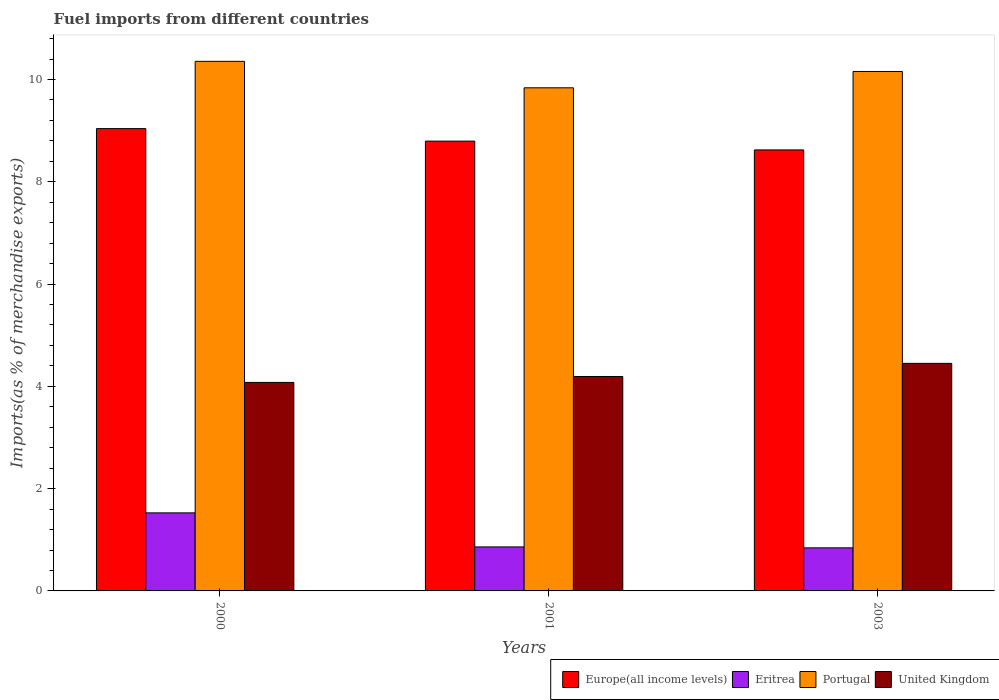How many groups of bars are there?
Provide a short and direct response. 3. Are the number of bars on each tick of the X-axis equal?
Make the answer very short. Yes. How many bars are there on the 3rd tick from the left?
Give a very brief answer. 4. What is the percentage of imports to different countries in Europe(all income levels) in 2001?
Ensure brevity in your answer.  8.8. Across all years, what is the maximum percentage of imports to different countries in Eritrea?
Your answer should be very brief. 1.53. Across all years, what is the minimum percentage of imports to different countries in United Kingdom?
Offer a very short reply. 4.08. What is the total percentage of imports to different countries in Europe(all income levels) in the graph?
Offer a terse response. 26.46. What is the difference between the percentage of imports to different countries in Eritrea in 2001 and that in 2003?
Keep it short and to the point. 0.02. What is the difference between the percentage of imports to different countries in Portugal in 2000 and the percentage of imports to different countries in United Kingdom in 2003?
Your answer should be compact. 5.91. What is the average percentage of imports to different countries in United Kingdom per year?
Keep it short and to the point. 4.24. In the year 2000, what is the difference between the percentage of imports to different countries in Europe(all income levels) and percentage of imports to different countries in United Kingdom?
Provide a succinct answer. 4.96. In how many years, is the percentage of imports to different countries in Eritrea greater than 8 %?
Give a very brief answer. 0. What is the ratio of the percentage of imports to different countries in United Kingdom in 2000 to that in 2001?
Keep it short and to the point. 0.97. What is the difference between the highest and the second highest percentage of imports to different countries in Portugal?
Ensure brevity in your answer.  0.2. What is the difference between the highest and the lowest percentage of imports to different countries in Portugal?
Make the answer very short. 0.52. Is the sum of the percentage of imports to different countries in Eritrea in 2000 and 2001 greater than the maximum percentage of imports to different countries in Europe(all income levels) across all years?
Keep it short and to the point. No. What does the 3rd bar from the left in 2001 represents?
Provide a short and direct response. Portugal. What does the 4th bar from the right in 2003 represents?
Ensure brevity in your answer.  Europe(all income levels). How many bars are there?
Provide a succinct answer. 12. Are all the bars in the graph horizontal?
Offer a very short reply. No. How many years are there in the graph?
Your answer should be compact. 3. Does the graph contain any zero values?
Give a very brief answer. No. Does the graph contain grids?
Your answer should be compact. No. How many legend labels are there?
Your answer should be very brief. 4. How are the legend labels stacked?
Your answer should be compact. Horizontal. What is the title of the graph?
Make the answer very short. Fuel imports from different countries. Does "Kiribati" appear as one of the legend labels in the graph?
Provide a short and direct response. No. What is the label or title of the X-axis?
Your answer should be compact. Years. What is the label or title of the Y-axis?
Your response must be concise. Imports(as % of merchandise exports). What is the Imports(as % of merchandise exports) in Europe(all income levels) in 2000?
Your response must be concise. 9.04. What is the Imports(as % of merchandise exports) of Eritrea in 2000?
Offer a terse response. 1.53. What is the Imports(as % of merchandise exports) in Portugal in 2000?
Provide a short and direct response. 10.36. What is the Imports(as % of merchandise exports) in United Kingdom in 2000?
Give a very brief answer. 4.08. What is the Imports(as % of merchandise exports) of Europe(all income levels) in 2001?
Offer a terse response. 8.8. What is the Imports(as % of merchandise exports) in Eritrea in 2001?
Your answer should be very brief. 0.86. What is the Imports(as % of merchandise exports) in Portugal in 2001?
Your answer should be very brief. 9.84. What is the Imports(as % of merchandise exports) in United Kingdom in 2001?
Provide a short and direct response. 4.19. What is the Imports(as % of merchandise exports) in Europe(all income levels) in 2003?
Provide a succinct answer. 8.62. What is the Imports(as % of merchandise exports) in Eritrea in 2003?
Provide a succinct answer. 0.84. What is the Imports(as % of merchandise exports) of Portugal in 2003?
Offer a terse response. 10.16. What is the Imports(as % of merchandise exports) in United Kingdom in 2003?
Offer a terse response. 4.45. Across all years, what is the maximum Imports(as % of merchandise exports) of Europe(all income levels)?
Your response must be concise. 9.04. Across all years, what is the maximum Imports(as % of merchandise exports) of Eritrea?
Keep it short and to the point. 1.53. Across all years, what is the maximum Imports(as % of merchandise exports) in Portugal?
Keep it short and to the point. 10.36. Across all years, what is the maximum Imports(as % of merchandise exports) of United Kingdom?
Provide a succinct answer. 4.45. Across all years, what is the minimum Imports(as % of merchandise exports) in Europe(all income levels)?
Your response must be concise. 8.62. Across all years, what is the minimum Imports(as % of merchandise exports) in Eritrea?
Offer a terse response. 0.84. Across all years, what is the minimum Imports(as % of merchandise exports) of Portugal?
Your answer should be compact. 9.84. Across all years, what is the minimum Imports(as % of merchandise exports) in United Kingdom?
Provide a succinct answer. 4.08. What is the total Imports(as % of merchandise exports) in Europe(all income levels) in the graph?
Ensure brevity in your answer.  26.46. What is the total Imports(as % of merchandise exports) of Eritrea in the graph?
Your answer should be very brief. 3.23. What is the total Imports(as % of merchandise exports) in Portugal in the graph?
Provide a succinct answer. 30.35. What is the total Imports(as % of merchandise exports) of United Kingdom in the graph?
Provide a succinct answer. 12.72. What is the difference between the Imports(as % of merchandise exports) of Europe(all income levels) in 2000 and that in 2001?
Offer a very short reply. 0.24. What is the difference between the Imports(as % of merchandise exports) of Eritrea in 2000 and that in 2001?
Give a very brief answer. 0.67. What is the difference between the Imports(as % of merchandise exports) of Portugal in 2000 and that in 2001?
Offer a very short reply. 0.52. What is the difference between the Imports(as % of merchandise exports) in United Kingdom in 2000 and that in 2001?
Keep it short and to the point. -0.12. What is the difference between the Imports(as % of merchandise exports) in Europe(all income levels) in 2000 and that in 2003?
Offer a very short reply. 0.42. What is the difference between the Imports(as % of merchandise exports) in Eritrea in 2000 and that in 2003?
Offer a terse response. 0.68. What is the difference between the Imports(as % of merchandise exports) of Portugal in 2000 and that in 2003?
Your answer should be compact. 0.2. What is the difference between the Imports(as % of merchandise exports) in United Kingdom in 2000 and that in 2003?
Ensure brevity in your answer.  -0.37. What is the difference between the Imports(as % of merchandise exports) of Europe(all income levels) in 2001 and that in 2003?
Your answer should be compact. 0.17. What is the difference between the Imports(as % of merchandise exports) in Eritrea in 2001 and that in 2003?
Make the answer very short. 0.02. What is the difference between the Imports(as % of merchandise exports) in Portugal in 2001 and that in 2003?
Give a very brief answer. -0.32. What is the difference between the Imports(as % of merchandise exports) of United Kingdom in 2001 and that in 2003?
Your answer should be compact. -0.26. What is the difference between the Imports(as % of merchandise exports) in Europe(all income levels) in 2000 and the Imports(as % of merchandise exports) in Eritrea in 2001?
Give a very brief answer. 8.18. What is the difference between the Imports(as % of merchandise exports) of Europe(all income levels) in 2000 and the Imports(as % of merchandise exports) of Portugal in 2001?
Give a very brief answer. -0.8. What is the difference between the Imports(as % of merchandise exports) of Europe(all income levels) in 2000 and the Imports(as % of merchandise exports) of United Kingdom in 2001?
Offer a terse response. 4.85. What is the difference between the Imports(as % of merchandise exports) in Eritrea in 2000 and the Imports(as % of merchandise exports) in Portugal in 2001?
Give a very brief answer. -8.31. What is the difference between the Imports(as % of merchandise exports) in Eritrea in 2000 and the Imports(as % of merchandise exports) in United Kingdom in 2001?
Offer a terse response. -2.67. What is the difference between the Imports(as % of merchandise exports) of Portugal in 2000 and the Imports(as % of merchandise exports) of United Kingdom in 2001?
Offer a terse response. 6.16. What is the difference between the Imports(as % of merchandise exports) in Europe(all income levels) in 2000 and the Imports(as % of merchandise exports) in Eritrea in 2003?
Ensure brevity in your answer.  8.2. What is the difference between the Imports(as % of merchandise exports) in Europe(all income levels) in 2000 and the Imports(as % of merchandise exports) in Portugal in 2003?
Make the answer very short. -1.12. What is the difference between the Imports(as % of merchandise exports) in Europe(all income levels) in 2000 and the Imports(as % of merchandise exports) in United Kingdom in 2003?
Provide a succinct answer. 4.59. What is the difference between the Imports(as % of merchandise exports) in Eritrea in 2000 and the Imports(as % of merchandise exports) in Portugal in 2003?
Your answer should be very brief. -8.63. What is the difference between the Imports(as % of merchandise exports) in Eritrea in 2000 and the Imports(as % of merchandise exports) in United Kingdom in 2003?
Provide a short and direct response. -2.92. What is the difference between the Imports(as % of merchandise exports) of Portugal in 2000 and the Imports(as % of merchandise exports) of United Kingdom in 2003?
Offer a terse response. 5.91. What is the difference between the Imports(as % of merchandise exports) in Europe(all income levels) in 2001 and the Imports(as % of merchandise exports) in Eritrea in 2003?
Give a very brief answer. 7.95. What is the difference between the Imports(as % of merchandise exports) in Europe(all income levels) in 2001 and the Imports(as % of merchandise exports) in Portugal in 2003?
Offer a very short reply. -1.36. What is the difference between the Imports(as % of merchandise exports) in Europe(all income levels) in 2001 and the Imports(as % of merchandise exports) in United Kingdom in 2003?
Your answer should be very brief. 4.35. What is the difference between the Imports(as % of merchandise exports) of Eritrea in 2001 and the Imports(as % of merchandise exports) of Portugal in 2003?
Your response must be concise. -9.3. What is the difference between the Imports(as % of merchandise exports) in Eritrea in 2001 and the Imports(as % of merchandise exports) in United Kingdom in 2003?
Ensure brevity in your answer.  -3.59. What is the difference between the Imports(as % of merchandise exports) of Portugal in 2001 and the Imports(as % of merchandise exports) of United Kingdom in 2003?
Provide a succinct answer. 5.39. What is the average Imports(as % of merchandise exports) in Europe(all income levels) per year?
Your answer should be compact. 8.82. What is the average Imports(as % of merchandise exports) of Eritrea per year?
Offer a terse response. 1.08. What is the average Imports(as % of merchandise exports) of Portugal per year?
Ensure brevity in your answer.  10.12. What is the average Imports(as % of merchandise exports) in United Kingdom per year?
Provide a short and direct response. 4.24. In the year 2000, what is the difference between the Imports(as % of merchandise exports) of Europe(all income levels) and Imports(as % of merchandise exports) of Eritrea?
Ensure brevity in your answer.  7.51. In the year 2000, what is the difference between the Imports(as % of merchandise exports) of Europe(all income levels) and Imports(as % of merchandise exports) of Portugal?
Your answer should be compact. -1.32. In the year 2000, what is the difference between the Imports(as % of merchandise exports) in Europe(all income levels) and Imports(as % of merchandise exports) in United Kingdom?
Your response must be concise. 4.96. In the year 2000, what is the difference between the Imports(as % of merchandise exports) in Eritrea and Imports(as % of merchandise exports) in Portugal?
Provide a short and direct response. -8.83. In the year 2000, what is the difference between the Imports(as % of merchandise exports) in Eritrea and Imports(as % of merchandise exports) in United Kingdom?
Provide a succinct answer. -2.55. In the year 2000, what is the difference between the Imports(as % of merchandise exports) in Portugal and Imports(as % of merchandise exports) in United Kingdom?
Make the answer very short. 6.28. In the year 2001, what is the difference between the Imports(as % of merchandise exports) of Europe(all income levels) and Imports(as % of merchandise exports) of Eritrea?
Your answer should be very brief. 7.94. In the year 2001, what is the difference between the Imports(as % of merchandise exports) of Europe(all income levels) and Imports(as % of merchandise exports) of Portugal?
Give a very brief answer. -1.04. In the year 2001, what is the difference between the Imports(as % of merchandise exports) of Europe(all income levels) and Imports(as % of merchandise exports) of United Kingdom?
Make the answer very short. 4.6. In the year 2001, what is the difference between the Imports(as % of merchandise exports) in Eritrea and Imports(as % of merchandise exports) in Portugal?
Ensure brevity in your answer.  -8.98. In the year 2001, what is the difference between the Imports(as % of merchandise exports) in Eritrea and Imports(as % of merchandise exports) in United Kingdom?
Your answer should be very brief. -3.33. In the year 2001, what is the difference between the Imports(as % of merchandise exports) in Portugal and Imports(as % of merchandise exports) in United Kingdom?
Provide a short and direct response. 5.64. In the year 2003, what is the difference between the Imports(as % of merchandise exports) in Europe(all income levels) and Imports(as % of merchandise exports) in Eritrea?
Provide a short and direct response. 7.78. In the year 2003, what is the difference between the Imports(as % of merchandise exports) in Europe(all income levels) and Imports(as % of merchandise exports) in Portugal?
Your answer should be compact. -1.53. In the year 2003, what is the difference between the Imports(as % of merchandise exports) in Europe(all income levels) and Imports(as % of merchandise exports) in United Kingdom?
Ensure brevity in your answer.  4.17. In the year 2003, what is the difference between the Imports(as % of merchandise exports) in Eritrea and Imports(as % of merchandise exports) in Portugal?
Your response must be concise. -9.32. In the year 2003, what is the difference between the Imports(as % of merchandise exports) of Eritrea and Imports(as % of merchandise exports) of United Kingdom?
Provide a succinct answer. -3.61. In the year 2003, what is the difference between the Imports(as % of merchandise exports) of Portugal and Imports(as % of merchandise exports) of United Kingdom?
Provide a succinct answer. 5.71. What is the ratio of the Imports(as % of merchandise exports) of Europe(all income levels) in 2000 to that in 2001?
Your answer should be very brief. 1.03. What is the ratio of the Imports(as % of merchandise exports) in Eritrea in 2000 to that in 2001?
Your response must be concise. 1.77. What is the ratio of the Imports(as % of merchandise exports) of Portugal in 2000 to that in 2001?
Give a very brief answer. 1.05. What is the ratio of the Imports(as % of merchandise exports) of United Kingdom in 2000 to that in 2001?
Provide a succinct answer. 0.97. What is the ratio of the Imports(as % of merchandise exports) in Europe(all income levels) in 2000 to that in 2003?
Make the answer very short. 1.05. What is the ratio of the Imports(as % of merchandise exports) of Eritrea in 2000 to that in 2003?
Provide a succinct answer. 1.81. What is the ratio of the Imports(as % of merchandise exports) of Portugal in 2000 to that in 2003?
Keep it short and to the point. 1.02. What is the ratio of the Imports(as % of merchandise exports) in United Kingdom in 2000 to that in 2003?
Keep it short and to the point. 0.92. What is the ratio of the Imports(as % of merchandise exports) in Europe(all income levels) in 2001 to that in 2003?
Offer a very short reply. 1.02. What is the ratio of the Imports(as % of merchandise exports) of Eritrea in 2001 to that in 2003?
Offer a very short reply. 1.02. What is the ratio of the Imports(as % of merchandise exports) in Portugal in 2001 to that in 2003?
Your answer should be very brief. 0.97. What is the ratio of the Imports(as % of merchandise exports) of United Kingdom in 2001 to that in 2003?
Make the answer very short. 0.94. What is the difference between the highest and the second highest Imports(as % of merchandise exports) of Europe(all income levels)?
Offer a very short reply. 0.24. What is the difference between the highest and the second highest Imports(as % of merchandise exports) of Eritrea?
Keep it short and to the point. 0.67. What is the difference between the highest and the second highest Imports(as % of merchandise exports) in Portugal?
Provide a short and direct response. 0.2. What is the difference between the highest and the second highest Imports(as % of merchandise exports) of United Kingdom?
Give a very brief answer. 0.26. What is the difference between the highest and the lowest Imports(as % of merchandise exports) of Europe(all income levels)?
Provide a succinct answer. 0.42. What is the difference between the highest and the lowest Imports(as % of merchandise exports) in Eritrea?
Your response must be concise. 0.68. What is the difference between the highest and the lowest Imports(as % of merchandise exports) in Portugal?
Ensure brevity in your answer.  0.52. What is the difference between the highest and the lowest Imports(as % of merchandise exports) of United Kingdom?
Your answer should be compact. 0.37. 